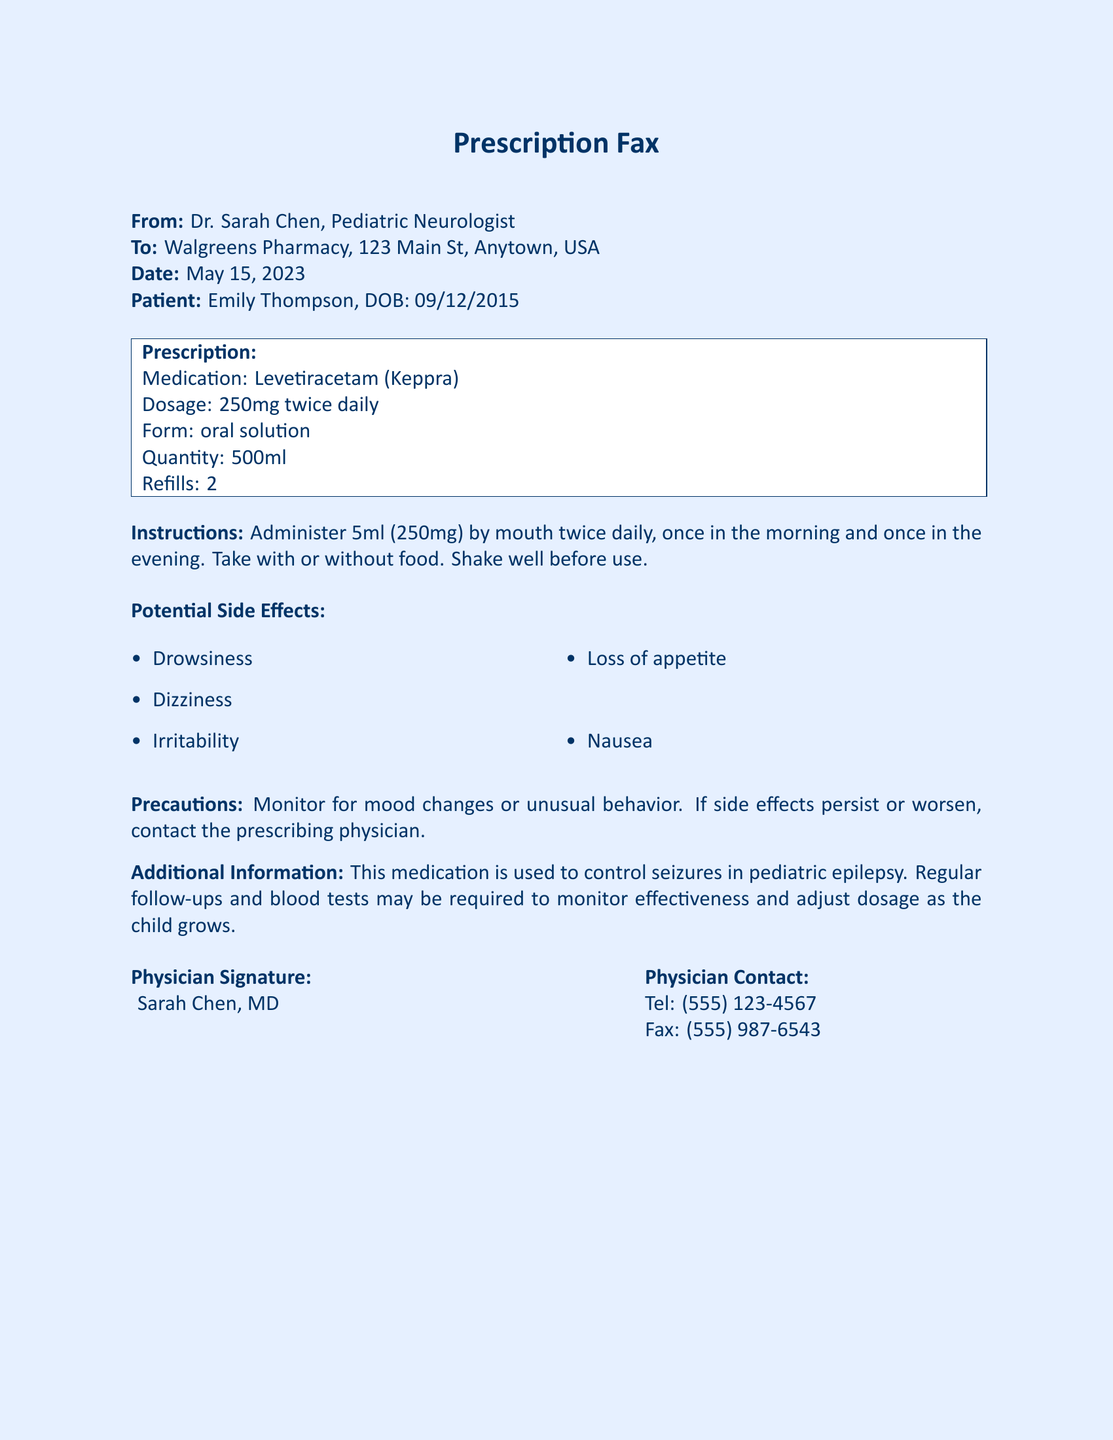What is the patient's name? The patient's name is mentioned in the header of the fax as Emily Thompson.
Answer: Emily Thompson What is the medication prescribed? The medication prescribed is specified in the prescription section of the fax.
Answer: Levetiracetam (Keppra) What is the dosage of the medication? The dosage is listed directly in the prescription section of the document.
Answer: 250mg twice daily How much of the medication should be administered at a time? The administration instructions indicate how much medication to take at once.
Answer: 5ml What are two potential side effects of the medication? The potential side effects are listed in bullet points in the document.
Answer: Drowsiness, Dizziness How many refills are provided in the prescription? The number of refills is explicitly stated in the prescription details.
Answer: 2 What should be monitored while the child is on this medication? The precautions section specifies what to monitor for while on the medication.
Answer: Mood changes or unusual behavior Who is the prescribing physician? The physician's name is provided at the end of the fax.
Answer: Sarah Chen What is the quantity of medication prescribed? The quantity is listed in the prescription as part of the medication information.
Answer: 500ml 